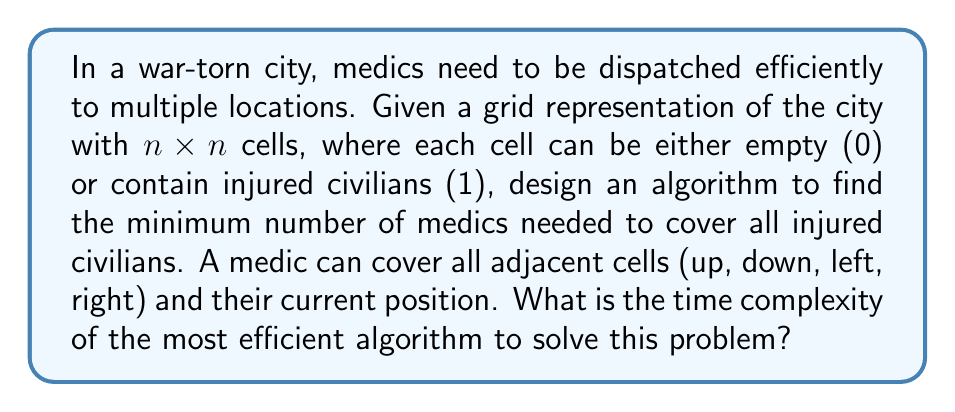Teach me how to tackle this problem. To solve this problem efficiently, we can use a greedy approach combined with a sweep line algorithm. Here's a step-by-step explanation of the algorithm and its time complexity analysis:

1. Scan the grid row by row, from top to bottom.
   Time: $O(n^2)$

2. For each row, maintain a list of uncovered injured civilians.
   Space: $O(n)$

3. For each cell in the current row:
   a. If it contains an injured civilian (1), add it to the list if not already covered.
   b. If the list is not empty and the current cell can cover any uncovered civilians:
      - Place a medic at the current cell.
      - Remove all civilians that can be covered by this medic from the list.
   Time per row: $O(n)$

4. After processing each row, if there are any remaining uncovered civilians in the list, place medics to cover them.
   Time per row: $O(n)$

5. Repeat steps 3-4 for all rows.
   Total time: $O(n^2)$

The time complexity analysis:
- Scanning the entire grid: $O(n^2)$
- Processing each cell and managing the list of uncovered civilians: $O(n)$ per row, for $n$ rows: $O(n^2)$
- The operations within each cell (checking coverage, placing medics) are constant time: $O(1)$

Therefore, the overall time complexity of this algorithm is $O(n^2)$, which is the most efficient possible as we need to examine each cell at least once.

Space complexity:
- The grid itself: $O(n^2)$
- The list of uncovered civilians: $O(n)$

Total space complexity: $O(n^2)$

This algorithm ensures that we use the minimum number of medics possible while covering all injured civilians in the most time-efficient manner.
Answer: The time complexity of the most efficient algorithm to solve this problem is $O(n^2)$, where $n$ is the size of one dimension of the $n \times n$ grid representing the war-torn city. 